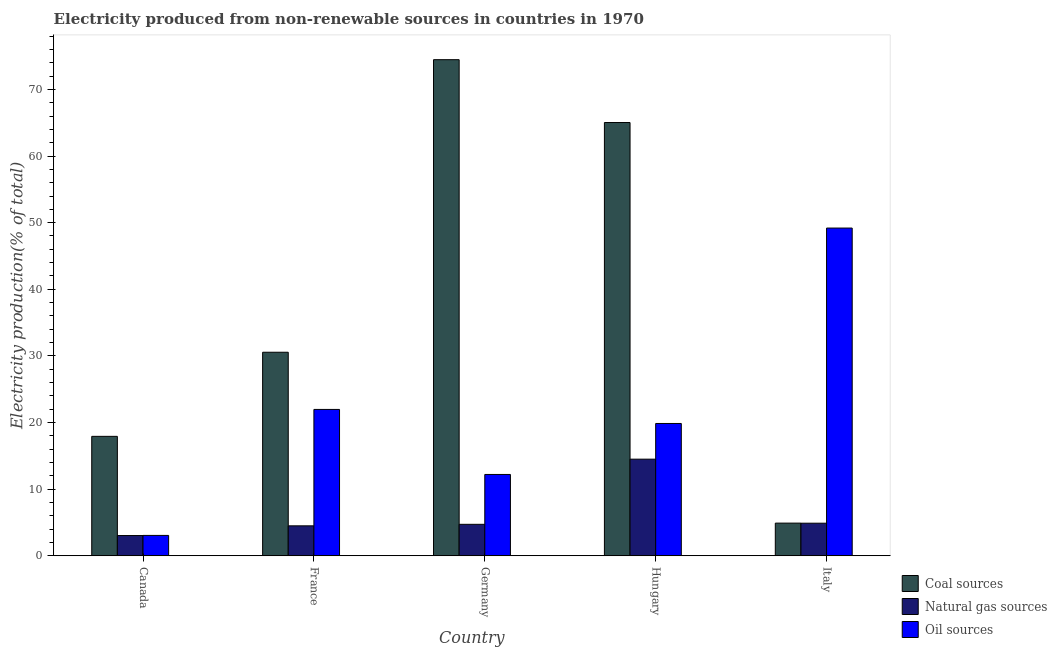How many different coloured bars are there?
Make the answer very short. 3. Are the number of bars per tick equal to the number of legend labels?
Your answer should be very brief. Yes. Are the number of bars on each tick of the X-axis equal?
Provide a succinct answer. Yes. How many bars are there on the 1st tick from the left?
Provide a short and direct response. 3. What is the label of the 5th group of bars from the left?
Make the answer very short. Italy. What is the percentage of electricity produced by coal in Italy?
Your answer should be very brief. 4.9. Across all countries, what is the maximum percentage of electricity produced by oil sources?
Offer a terse response. 49.19. Across all countries, what is the minimum percentage of electricity produced by coal?
Ensure brevity in your answer.  4.9. In which country was the percentage of electricity produced by coal minimum?
Ensure brevity in your answer.  Italy. What is the total percentage of electricity produced by oil sources in the graph?
Give a very brief answer. 106.29. What is the difference between the percentage of electricity produced by natural gas in France and that in Hungary?
Make the answer very short. -10.01. What is the difference between the percentage of electricity produced by oil sources in Italy and the percentage of electricity produced by coal in Germany?
Your answer should be very brief. -25.27. What is the average percentage of electricity produced by natural gas per country?
Provide a succinct answer. 6.33. What is the difference between the percentage of electricity produced by coal and percentage of electricity produced by natural gas in Italy?
Keep it short and to the point. 0.01. In how many countries, is the percentage of electricity produced by natural gas greater than 12 %?
Give a very brief answer. 1. What is the ratio of the percentage of electricity produced by natural gas in France to that in Germany?
Your answer should be compact. 0.95. Is the percentage of electricity produced by natural gas in France less than that in Italy?
Ensure brevity in your answer.  Yes. What is the difference between the highest and the second highest percentage of electricity produced by natural gas?
Offer a very short reply. 9.61. What is the difference between the highest and the lowest percentage of electricity produced by natural gas?
Give a very brief answer. 11.46. In how many countries, is the percentage of electricity produced by coal greater than the average percentage of electricity produced by coal taken over all countries?
Provide a succinct answer. 2. What does the 3rd bar from the left in Canada represents?
Your response must be concise. Oil sources. What does the 3rd bar from the right in Hungary represents?
Your answer should be compact. Coal sources. Is it the case that in every country, the sum of the percentage of electricity produced by coal and percentage of electricity produced by natural gas is greater than the percentage of electricity produced by oil sources?
Provide a short and direct response. No. How many bars are there?
Your answer should be very brief. 15. Are the values on the major ticks of Y-axis written in scientific E-notation?
Your response must be concise. No. How are the legend labels stacked?
Your response must be concise. Vertical. What is the title of the graph?
Ensure brevity in your answer.  Electricity produced from non-renewable sources in countries in 1970. Does "Transport equipments" appear as one of the legend labels in the graph?
Give a very brief answer. No. What is the label or title of the X-axis?
Give a very brief answer. Country. What is the label or title of the Y-axis?
Keep it short and to the point. Electricity production(% of total). What is the Electricity production(% of total) in Coal sources in Canada?
Offer a terse response. 17.93. What is the Electricity production(% of total) of Natural gas sources in Canada?
Provide a short and direct response. 3.04. What is the Electricity production(% of total) of Oil sources in Canada?
Your answer should be compact. 3.06. What is the Electricity production(% of total) in Coal sources in France?
Your response must be concise. 30.55. What is the Electricity production(% of total) in Natural gas sources in France?
Offer a very short reply. 4.5. What is the Electricity production(% of total) in Oil sources in France?
Your answer should be compact. 21.97. What is the Electricity production(% of total) of Coal sources in Germany?
Make the answer very short. 74.46. What is the Electricity production(% of total) of Natural gas sources in Germany?
Your answer should be very brief. 4.72. What is the Electricity production(% of total) of Oil sources in Germany?
Offer a very short reply. 12.21. What is the Electricity production(% of total) in Coal sources in Hungary?
Provide a succinct answer. 65.03. What is the Electricity production(% of total) of Natural gas sources in Hungary?
Keep it short and to the point. 14.5. What is the Electricity production(% of total) of Oil sources in Hungary?
Ensure brevity in your answer.  19.86. What is the Electricity production(% of total) of Coal sources in Italy?
Your answer should be very brief. 4.9. What is the Electricity production(% of total) in Natural gas sources in Italy?
Your response must be concise. 4.89. What is the Electricity production(% of total) of Oil sources in Italy?
Offer a very short reply. 49.19. Across all countries, what is the maximum Electricity production(% of total) in Coal sources?
Give a very brief answer. 74.46. Across all countries, what is the maximum Electricity production(% of total) of Natural gas sources?
Keep it short and to the point. 14.5. Across all countries, what is the maximum Electricity production(% of total) in Oil sources?
Ensure brevity in your answer.  49.19. Across all countries, what is the minimum Electricity production(% of total) in Coal sources?
Your response must be concise. 4.9. Across all countries, what is the minimum Electricity production(% of total) of Natural gas sources?
Your answer should be very brief. 3.04. Across all countries, what is the minimum Electricity production(% of total) in Oil sources?
Provide a short and direct response. 3.06. What is the total Electricity production(% of total) in Coal sources in the graph?
Provide a short and direct response. 192.88. What is the total Electricity production(% of total) in Natural gas sources in the graph?
Keep it short and to the point. 31.66. What is the total Electricity production(% of total) in Oil sources in the graph?
Provide a short and direct response. 106.29. What is the difference between the Electricity production(% of total) in Coal sources in Canada and that in France?
Make the answer very short. -12.63. What is the difference between the Electricity production(% of total) in Natural gas sources in Canada and that in France?
Give a very brief answer. -1.46. What is the difference between the Electricity production(% of total) of Oil sources in Canada and that in France?
Give a very brief answer. -18.91. What is the difference between the Electricity production(% of total) of Coal sources in Canada and that in Germany?
Your answer should be compact. -56.54. What is the difference between the Electricity production(% of total) in Natural gas sources in Canada and that in Germany?
Offer a terse response. -1.68. What is the difference between the Electricity production(% of total) in Oil sources in Canada and that in Germany?
Offer a very short reply. -9.15. What is the difference between the Electricity production(% of total) in Coal sources in Canada and that in Hungary?
Ensure brevity in your answer.  -47.11. What is the difference between the Electricity production(% of total) in Natural gas sources in Canada and that in Hungary?
Provide a succinct answer. -11.46. What is the difference between the Electricity production(% of total) in Oil sources in Canada and that in Hungary?
Your answer should be very brief. -16.8. What is the difference between the Electricity production(% of total) of Coal sources in Canada and that in Italy?
Make the answer very short. 13.02. What is the difference between the Electricity production(% of total) of Natural gas sources in Canada and that in Italy?
Offer a very short reply. -1.85. What is the difference between the Electricity production(% of total) of Oil sources in Canada and that in Italy?
Offer a terse response. -46.13. What is the difference between the Electricity production(% of total) in Coal sources in France and that in Germany?
Your answer should be very brief. -43.91. What is the difference between the Electricity production(% of total) in Natural gas sources in France and that in Germany?
Offer a terse response. -0.23. What is the difference between the Electricity production(% of total) in Oil sources in France and that in Germany?
Keep it short and to the point. 9.76. What is the difference between the Electricity production(% of total) in Coal sources in France and that in Hungary?
Make the answer very short. -34.48. What is the difference between the Electricity production(% of total) of Natural gas sources in France and that in Hungary?
Provide a succinct answer. -10.01. What is the difference between the Electricity production(% of total) of Oil sources in France and that in Hungary?
Your answer should be compact. 2.11. What is the difference between the Electricity production(% of total) in Coal sources in France and that in Italy?
Offer a very short reply. 25.65. What is the difference between the Electricity production(% of total) of Natural gas sources in France and that in Italy?
Offer a terse response. -0.4. What is the difference between the Electricity production(% of total) in Oil sources in France and that in Italy?
Provide a short and direct response. -27.22. What is the difference between the Electricity production(% of total) in Coal sources in Germany and that in Hungary?
Give a very brief answer. 9.43. What is the difference between the Electricity production(% of total) of Natural gas sources in Germany and that in Hungary?
Keep it short and to the point. -9.78. What is the difference between the Electricity production(% of total) in Oil sources in Germany and that in Hungary?
Offer a very short reply. -7.65. What is the difference between the Electricity production(% of total) in Coal sources in Germany and that in Italy?
Provide a succinct answer. 69.56. What is the difference between the Electricity production(% of total) of Natural gas sources in Germany and that in Italy?
Your response must be concise. -0.17. What is the difference between the Electricity production(% of total) of Oil sources in Germany and that in Italy?
Offer a terse response. -36.98. What is the difference between the Electricity production(% of total) of Coal sources in Hungary and that in Italy?
Give a very brief answer. 60.13. What is the difference between the Electricity production(% of total) of Natural gas sources in Hungary and that in Italy?
Ensure brevity in your answer.  9.61. What is the difference between the Electricity production(% of total) in Oil sources in Hungary and that in Italy?
Make the answer very short. -29.33. What is the difference between the Electricity production(% of total) in Coal sources in Canada and the Electricity production(% of total) in Natural gas sources in France?
Your answer should be compact. 13.43. What is the difference between the Electricity production(% of total) in Coal sources in Canada and the Electricity production(% of total) in Oil sources in France?
Provide a succinct answer. -4.04. What is the difference between the Electricity production(% of total) in Natural gas sources in Canada and the Electricity production(% of total) in Oil sources in France?
Your response must be concise. -18.93. What is the difference between the Electricity production(% of total) in Coal sources in Canada and the Electricity production(% of total) in Natural gas sources in Germany?
Your answer should be very brief. 13.2. What is the difference between the Electricity production(% of total) in Coal sources in Canada and the Electricity production(% of total) in Oil sources in Germany?
Your response must be concise. 5.72. What is the difference between the Electricity production(% of total) of Natural gas sources in Canada and the Electricity production(% of total) of Oil sources in Germany?
Provide a short and direct response. -9.17. What is the difference between the Electricity production(% of total) in Coal sources in Canada and the Electricity production(% of total) in Natural gas sources in Hungary?
Your response must be concise. 3.42. What is the difference between the Electricity production(% of total) of Coal sources in Canada and the Electricity production(% of total) of Oil sources in Hungary?
Your answer should be very brief. -1.93. What is the difference between the Electricity production(% of total) in Natural gas sources in Canada and the Electricity production(% of total) in Oil sources in Hungary?
Your answer should be very brief. -16.82. What is the difference between the Electricity production(% of total) of Coal sources in Canada and the Electricity production(% of total) of Natural gas sources in Italy?
Your answer should be compact. 13.03. What is the difference between the Electricity production(% of total) of Coal sources in Canada and the Electricity production(% of total) of Oil sources in Italy?
Provide a succinct answer. -31.26. What is the difference between the Electricity production(% of total) of Natural gas sources in Canada and the Electricity production(% of total) of Oil sources in Italy?
Ensure brevity in your answer.  -46.15. What is the difference between the Electricity production(% of total) in Coal sources in France and the Electricity production(% of total) in Natural gas sources in Germany?
Offer a very short reply. 25.83. What is the difference between the Electricity production(% of total) of Coal sources in France and the Electricity production(% of total) of Oil sources in Germany?
Provide a succinct answer. 18.34. What is the difference between the Electricity production(% of total) in Natural gas sources in France and the Electricity production(% of total) in Oil sources in Germany?
Make the answer very short. -7.71. What is the difference between the Electricity production(% of total) in Coal sources in France and the Electricity production(% of total) in Natural gas sources in Hungary?
Make the answer very short. 16.05. What is the difference between the Electricity production(% of total) of Coal sources in France and the Electricity production(% of total) of Oil sources in Hungary?
Offer a terse response. 10.69. What is the difference between the Electricity production(% of total) in Natural gas sources in France and the Electricity production(% of total) in Oil sources in Hungary?
Provide a short and direct response. -15.36. What is the difference between the Electricity production(% of total) of Coal sources in France and the Electricity production(% of total) of Natural gas sources in Italy?
Offer a very short reply. 25.66. What is the difference between the Electricity production(% of total) of Coal sources in France and the Electricity production(% of total) of Oil sources in Italy?
Keep it short and to the point. -18.64. What is the difference between the Electricity production(% of total) in Natural gas sources in France and the Electricity production(% of total) in Oil sources in Italy?
Ensure brevity in your answer.  -44.69. What is the difference between the Electricity production(% of total) in Coal sources in Germany and the Electricity production(% of total) in Natural gas sources in Hungary?
Offer a terse response. 59.96. What is the difference between the Electricity production(% of total) of Coal sources in Germany and the Electricity production(% of total) of Oil sources in Hungary?
Your answer should be very brief. 54.6. What is the difference between the Electricity production(% of total) in Natural gas sources in Germany and the Electricity production(% of total) in Oil sources in Hungary?
Ensure brevity in your answer.  -15.14. What is the difference between the Electricity production(% of total) of Coal sources in Germany and the Electricity production(% of total) of Natural gas sources in Italy?
Make the answer very short. 69.57. What is the difference between the Electricity production(% of total) in Coal sources in Germany and the Electricity production(% of total) in Oil sources in Italy?
Your answer should be compact. 25.27. What is the difference between the Electricity production(% of total) in Natural gas sources in Germany and the Electricity production(% of total) in Oil sources in Italy?
Ensure brevity in your answer.  -44.47. What is the difference between the Electricity production(% of total) of Coal sources in Hungary and the Electricity production(% of total) of Natural gas sources in Italy?
Your answer should be very brief. 60.14. What is the difference between the Electricity production(% of total) in Coal sources in Hungary and the Electricity production(% of total) in Oil sources in Italy?
Keep it short and to the point. 15.84. What is the difference between the Electricity production(% of total) in Natural gas sources in Hungary and the Electricity production(% of total) in Oil sources in Italy?
Provide a short and direct response. -34.69. What is the average Electricity production(% of total) in Coal sources per country?
Provide a succinct answer. 38.58. What is the average Electricity production(% of total) in Natural gas sources per country?
Provide a short and direct response. 6.33. What is the average Electricity production(% of total) in Oil sources per country?
Give a very brief answer. 21.26. What is the difference between the Electricity production(% of total) in Coal sources and Electricity production(% of total) in Natural gas sources in Canada?
Make the answer very short. 14.89. What is the difference between the Electricity production(% of total) in Coal sources and Electricity production(% of total) in Oil sources in Canada?
Offer a terse response. 14.87. What is the difference between the Electricity production(% of total) in Natural gas sources and Electricity production(% of total) in Oil sources in Canada?
Keep it short and to the point. -0.02. What is the difference between the Electricity production(% of total) in Coal sources and Electricity production(% of total) in Natural gas sources in France?
Your answer should be very brief. 26.06. What is the difference between the Electricity production(% of total) in Coal sources and Electricity production(% of total) in Oil sources in France?
Give a very brief answer. 8.59. What is the difference between the Electricity production(% of total) in Natural gas sources and Electricity production(% of total) in Oil sources in France?
Your answer should be very brief. -17.47. What is the difference between the Electricity production(% of total) of Coal sources and Electricity production(% of total) of Natural gas sources in Germany?
Ensure brevity in your answer.  69.74. What is the difference between the Electricity production(% of total) in Coal sources and Electricity production(% of total) in Oil sources in Germany?
Give a very brief answer. 62.26. What is the difference between the Electricity production(% of total) in Natural gas sources and Electricity production(% of total) in Oil sources in Germany?
Give a very brief answer. -7.48. What is the difference between the Electricity production(% of total) of Coal sources and Electricity production(% of total) of Natural gas sources in Hungary?
Provide a succinct answer. 50.53. What is the difference between the Electricity production(% of total) of Coal sources and Electricity production(% of total) of Oil sources in Hungary?
Your response must be concise. 45.17. What is the difference between the Electricity production(% of total) of Natural gas sources and Electricity production(% of total) of Oil sources in Hungary?
Keep it short and to the point. -5.36. What is the difference between the Electricity production(% of total) of Coal sources and Electricity production(% of total) of Natural gas sources in Italy?
Offer a very short reply. 0.01. What is the difference between the Electricity production(% of total) in Coal sources and Electricity production(% of total) in Oil sources in Italy?
Give a very brief answer. -44.29. What is the difference between the Electricity production(% of total) of Natural gas sources and Electricity production(% of total) of Oil sources in Italy?
Make the answer very short. -44.3. What is the ratio of the Electricity production(% of total) of Coal sources in Canada to that in France?
Offer a very short reply. 0.59. What is the ratio of the Electricity production(% of total) of Natural gas sources in Canada to that in France?
Give a very brief answer. 0.68. What is the ratio of the Electricity production(% of total) in Oil sources in Canada to that in France?
Keep it short and to the point. 0.14. What is the ratio of the Electricity production(% of total) in Coal sources in Canada to that in Germany?
Your response must be concise. 0.24. What is the ratio of the Electricity production(% of total) in Natural gas sources in Canada to that in Germany?
Ensure brevity in your answer.  0.64. What is the ratio of the Electricity production(% of total) of Oil sources in Canada to that in Germany?
Offer a very short reply. 0.25. What is the ratio of the Electricity production(% of total) in Coal sources in Canada to that in Hungary?
Your answer should be very brief. 0.28. What is the ratio of the Electricity production(% of total) in Natural gas sources in Canada to that in Hungary?
Provide a succinct answer. 0.21. What is the ratio of the Electricity production(% of total) in Oil sources in Canada to that in Hungary?
Keep it short and to the point. 0.15. What is the ratio of the Electricity production(% of total) in Coal sources in Canada to that in Italy?
Your response must be concise. 3.65. What is the ratio of the Electricity production(% of total) in Natural gas sources in Canada to that in Italy?
Your answer should be very brief. 0.62. What is the ratio of the Electricity production(% of total) in Oil sources in Canada to that in Italy?
Offer a terse response. 0.06. What is the ratio of the Electricity production(% of total) of Coal sources in France to that in Germany?
Make the answer very short. 0.41. What is the ratio of the Electricity production(% of total) in Natural gas sources in France to that in Germany?
Offer a very short reply. 0.95. What is the ratio of the Electricity production(% of total) of Oil sources in France to that in Germany?
Keep it short and to the point. 1.8. What is the ratio of the Electricity production(% of total) of Coal sources in France to that in Hungary?
Offer a very short reply. 0.47. What is the ratio of the Electricity production(% of total) of Natural gas sources in France to that in Hungary?
Provide a short and direct response. 0.31. What is the ratio of the Electricity production(% of total) in Oil sources in France to that in Hungary?
Provide a succinct answer. 1.11. What is the ratio of the Electricity production(% of total) in Coal sources in France to that in Italy?
Make the answer very short. 6.23. What is the ratio of the Electricity production(% of total) in Natural gas sources in France to that in Italy?
Give a very brief answer. 0.92. What is the ratio of the Electricity production(% of total) of Oil sources in France to that in Italy?
Keep it short and to the point. 0.45. What is the ratio of the Electricity production(% of total) of Coal sources in Germany to that in Hungary?
Offer a very short reply. 1.15. What is the ratio of the Electricity production(% of total) in Natural gas sources in Germany to that in Hungary?
Make the answer very short. 0.33. What is the ratio of the Electricity production(% of total) in Oil sources in Germany to that in Hungary?
Your response must be concise. 0.61. What is the ratio of the Electricity production(% of total) of Coal sources in Germany to that in Italy?
Ensure brevity in your answer.  15.18. What is the ratio of the Electricity production(% of total) in Natural gas sources in Germany to that in Italy?
Keep it short and to the point. 0.97. What is the ratio of the Electricity production(% of total) in Oil sources in Germany to that in Italy?
Your answer should be very brief. 0.25. What is the ratio of the Electricity production(% of total) of Coal sources in Hungary to that in Italy?
Give a very brief answer. 13.26. What is the ratio of the Electricity production(% of total) in Natural gas sources in Hungary to that in Italy?
Provide a short and direct response. 2.96. What is the ratio of the Electricity production(% of total) in Oil sources in Hungary to that in Italy?
Give a very brief answer. 0.4. What is the difference between the highest and the second highest Electricity production(% of total) of Coal sources?
Provide a succinct answer. 9.43. What is the difference between the highest and the second highest Electricity production(% of total) of Natural gas sources?
Your response must be concise. 9.61. What is the difference between the highest and the second highest Electricity production(% of total) of Oil sources?
Your response must be concise. 27.22. What is the difference between the highest and the lowest Electricity production(% of total) in Coal sources?
Your response must be concise. 69.56. What is the difference between the highest and the lowest Electricity production(% of total) in Natural gas sources?
Provide a short and direct response. 11.46. What is the difference between the highest and the lowest Electricity production(% of total) of Oil sources?
Your answer should be compact. 46.13. 